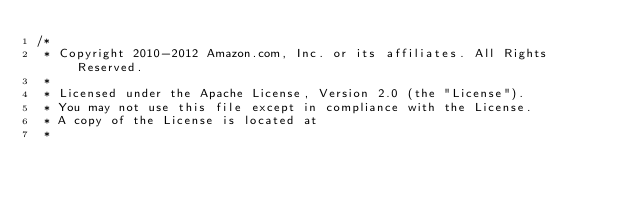<code> <loc_0><loc_0><loc_500><loc_500><_C_>/*
 * Copyright 2010-2012 Amazon.com, Inc. or its affiliates. All Rights Reserved.
 *
 * Licensed under the Apache License, Version 2.0 (the "License").
 * You may not use this file except in compliance with the License.
 * A copy of the License is located at
 *</code> 